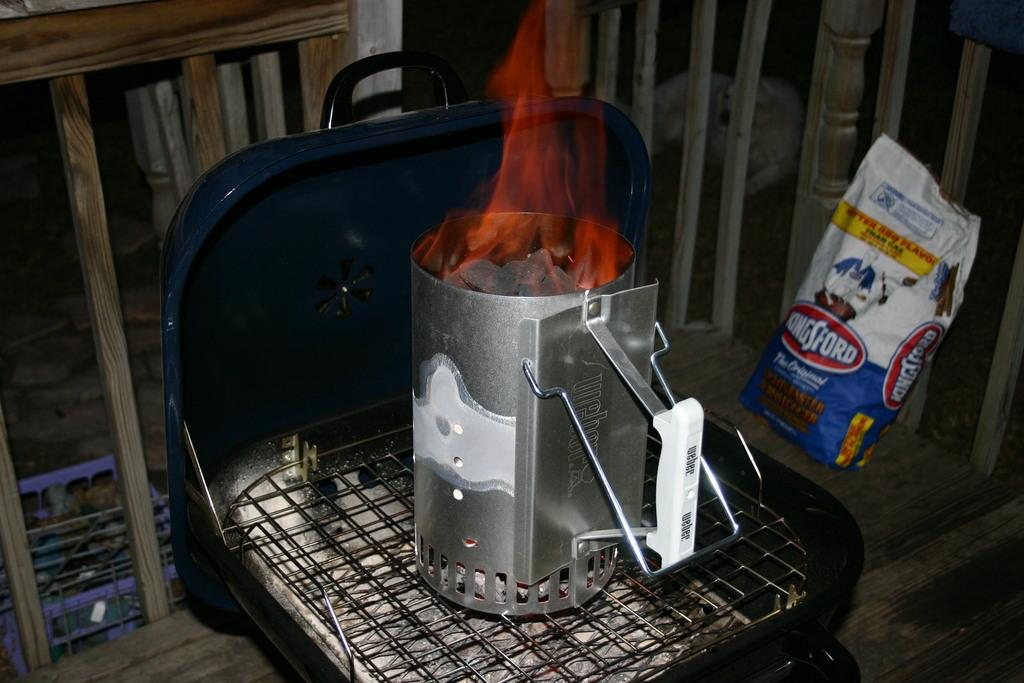<image>
Write a terse but informative summary of the picture. A bag of Kingsford charcoal leans against the wall near a grill. 